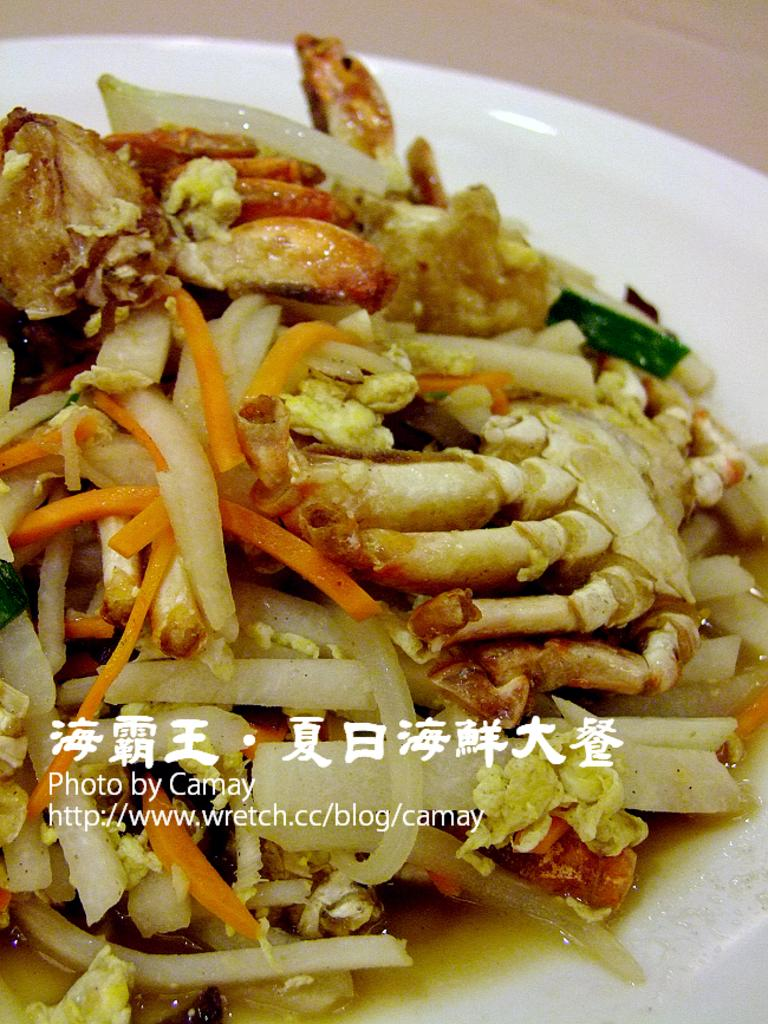What is on the plate in the image? A food item is present on the plate in the image. What type of pet can be seen playing with the food item on the plate in the image? There is no pet present in the image, and the food item is not being played with. 